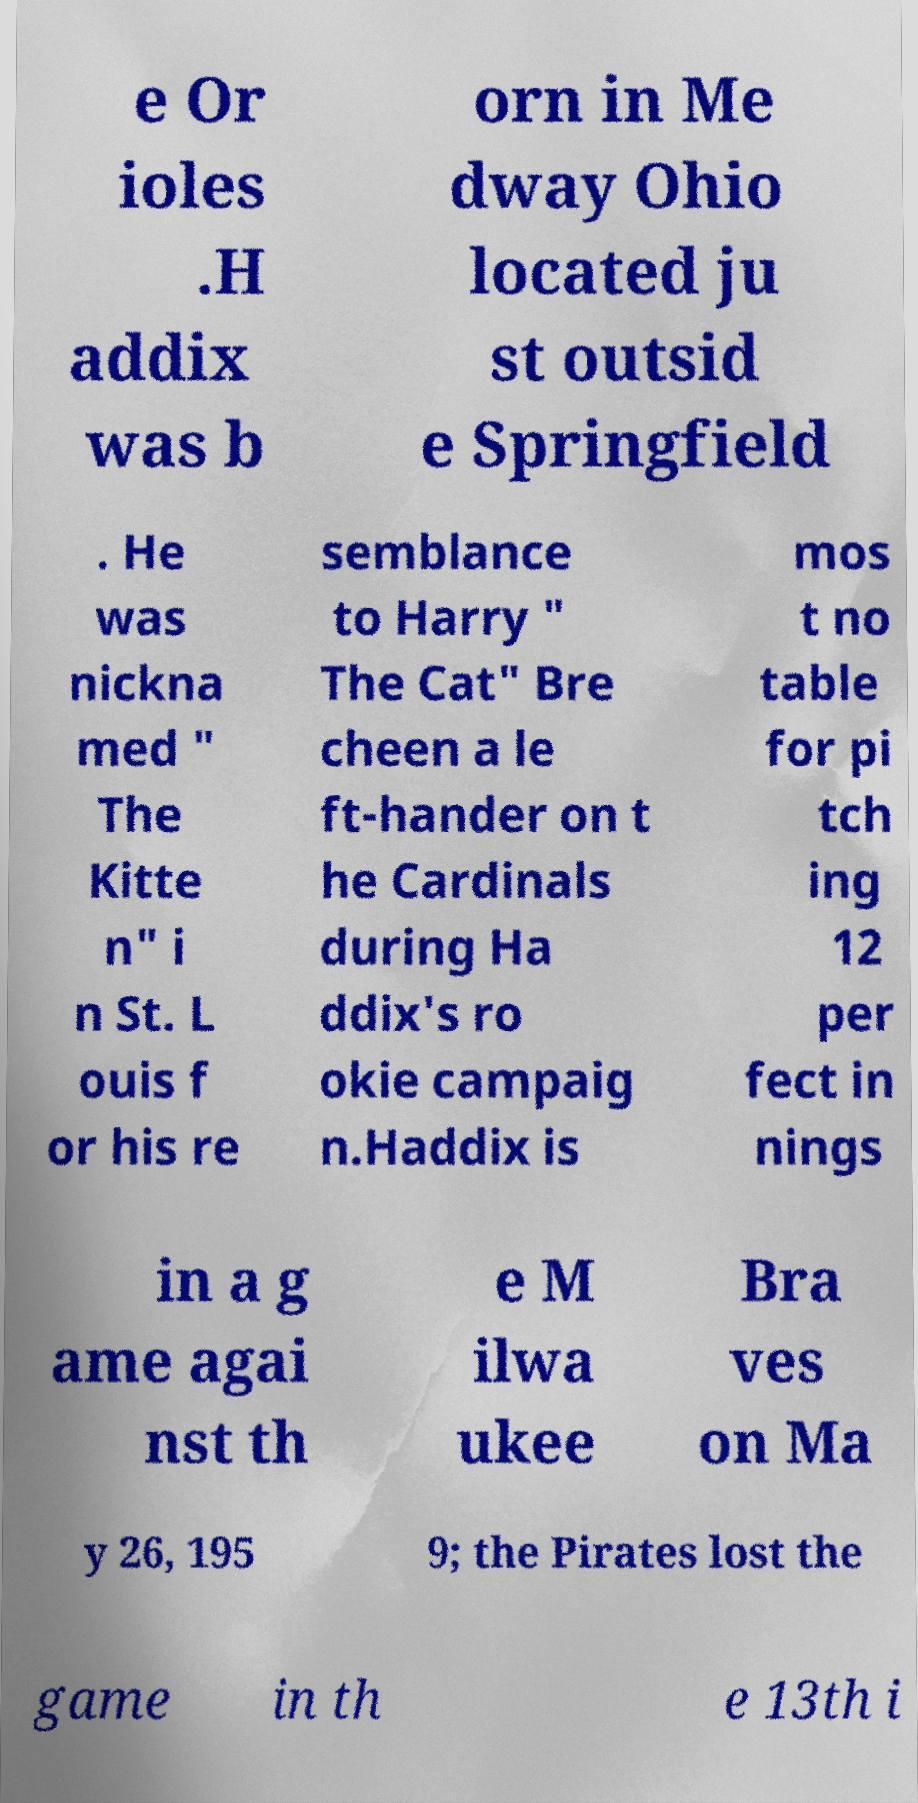For documentation purposes, I need the text within this image transcribed. Could you provide that? e Or ioles .H addix was b orn in Me dway Ohio located ju st outsid e Springfield . He was nickna med " The Kitte n" i n St. L ouis f or his re semblance to Harry " The Cat" Bre cheen a le ft-hander on t he Cardinals during Ha ddix's ro okie campaig n.Haddix is mos t no table for pi tch ing 12 per fect in nings in a g ame agai nst th e M ilwa ukee Bra ves on Ma y 26, 195 9; the Pirates lost the game in th e 13th i 